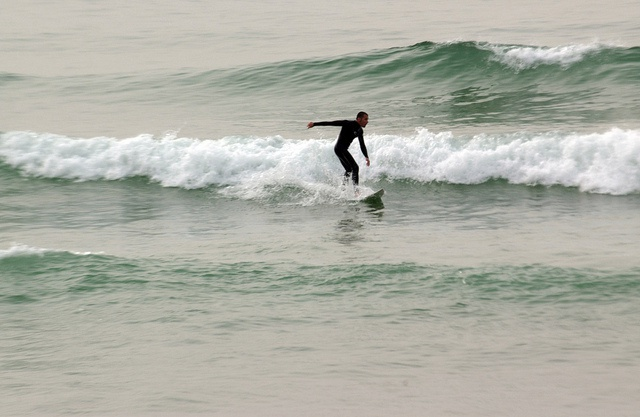Describe the objects in this image and their specific colors. I can see people in lightgray, black, darkgray, and gray tones and surfboard in lightgray, gray, darkgreen, and black tones in this image. 